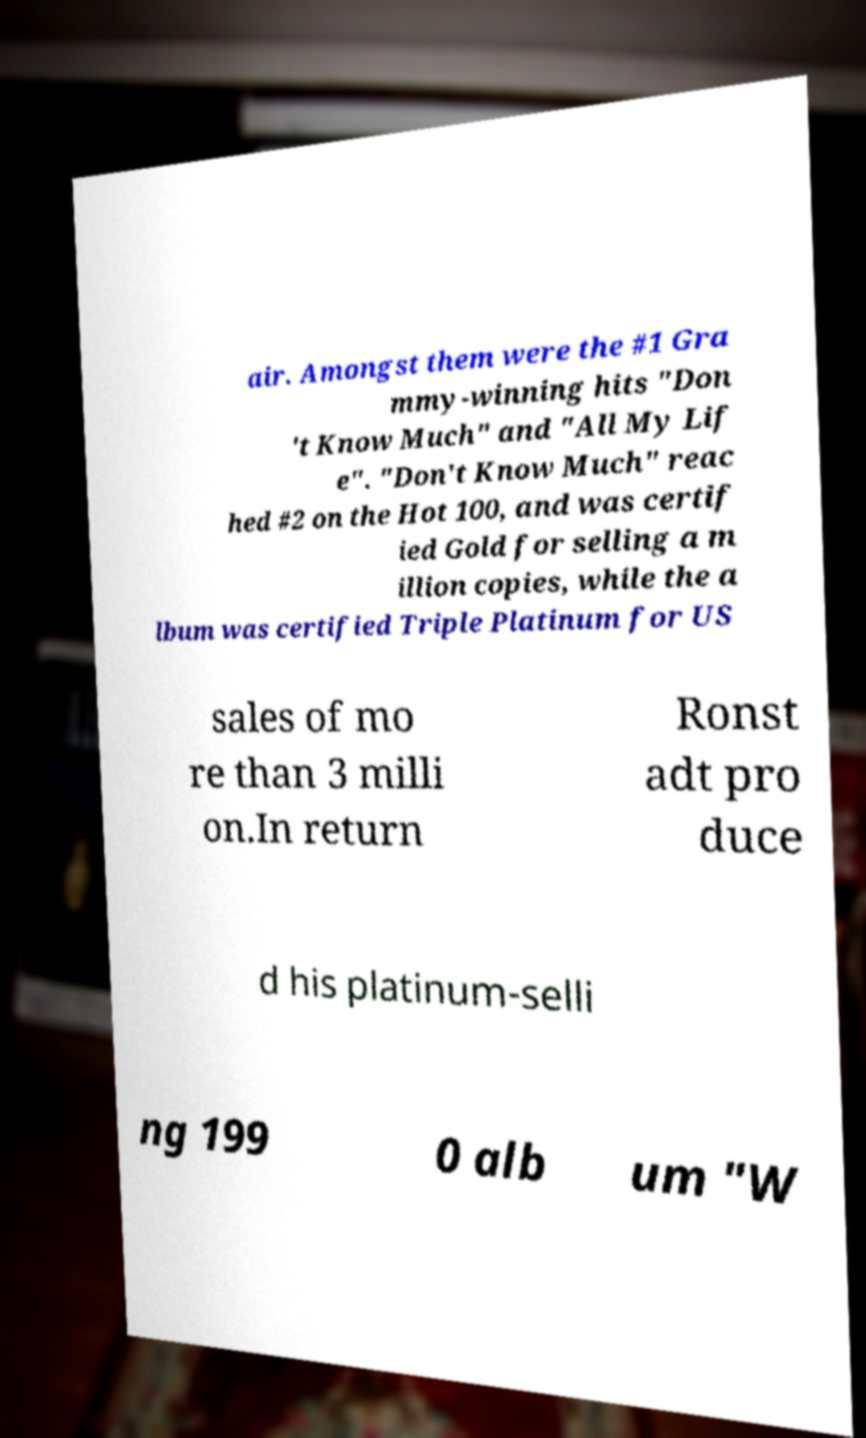Can you accurately transcribe the text from the provided image for me? air. Amongst them were the #1 Gra mmy-winning hits "Don 't Know Much" and "All My Lif e". "Don't Know Much" reac hed #2 on the Hot 100, and was certif ied Gold for selling a m illion copies, while the a lbum was certified Triple Platinum for US sales of mo re than 3 milli on.In return Ronst adt pro duce d his platinum-selli ng 199 0 alb um "W 